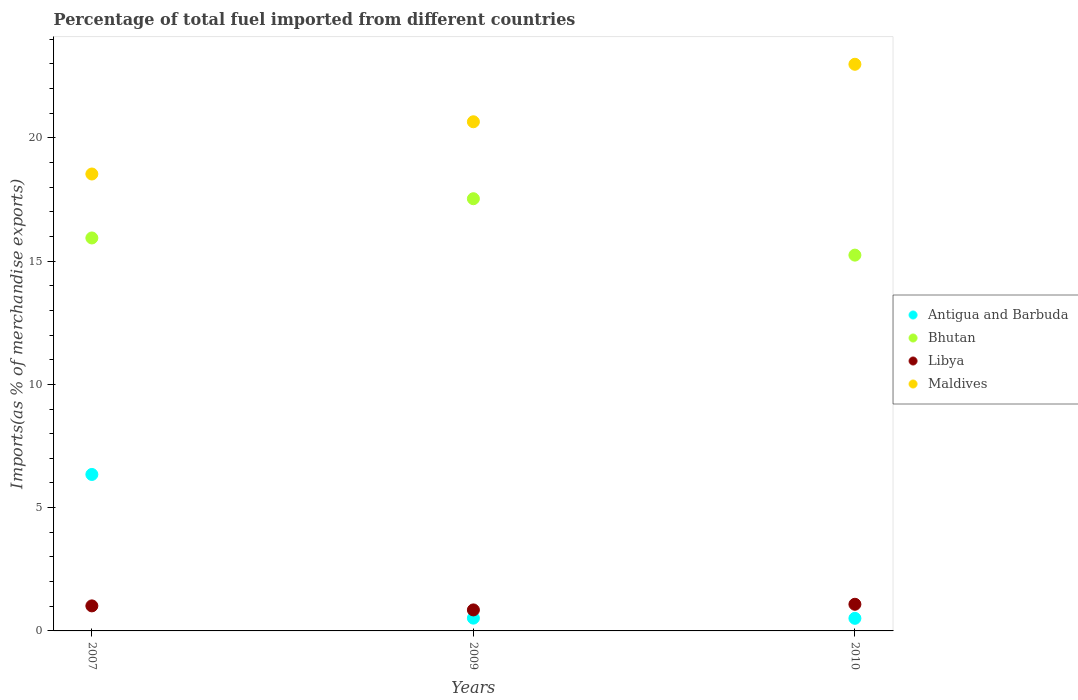How many different coloured dotlines are there?
Offer a terse response. 4. Is the number of dotlines equal to the number of legend labels?
Your answer should be compact. Yes. What is the percentage of imports to different countries in Libya in 2010?
Your answer should be compact. 1.08. Across all years, what is the maximum percentage of imports to different countries in Maldives?
Provide a succinct answer. 22.98. Across all years, what is the minimum percentage of imports to different countries in Bhutan?
Provide a short and direct response. 15.24. What is the total percentage of imports to different countries in Antigua and Barbuda in the graph?
Give a very brief answer. 7.38. What is the difference between the percentage of imports to different countries in Libya in 2009 and that in 2010?
Give a very brief answer. -0.23. What is the difference between the percentage of imports to different countries in Maldives in 2009 and the percentage of imports to different countries in Bhutan in 2007?
Offer a terse response. 4.71. What is the average percentage of imports to different countries in Bhutan per year?
Your answer should be very brief. 16.24. In the year 2010, what is the difference between the percentage of imports to different countries in Antigua and Barbuda and percentage of imports to different countries in Maldives?
Offer a terse response. -22.47. What is the ratio of the percentage of imports to different countries in Bhutan in 2009 to that in 2010?
Ensure brevity in your answer.  1.15. Is the percentage of imports to different countries in Antigua and Barbuda in 2007 less than that in 2010?
Offer a terse response. No. What is the difference between the highest and the second highest percentage of imports to different countries in Libya?
Your response must be concise. 0.07. What is the difference between the highest and the lowest percentage of imports to different countries in Maldives?
Your answer should be very brief. 4.45. In how many years, is the percentage of imports to different countries in Maldives greater than the average percentage of imports to different countries in Maldives taken over all years?
Your response must be concise. 1. Is the sum of the percentage of imports to different countries in Libya in 2007 and 2010 greater than the maximum percentage of imports to different countries in Bhutan across all years?
Your answer should be very brief. No. Is it the case that in every year, the sum of the percentage of imports to different countries in Antigua and Barbuda and percentage of imports to different countries in Libya  is greater than the percentage of imports to different countries in Maldives?
Offer a very short reply. No. Is the percentage of imports to different countries in Bhutan strictly greater than the percentage of imports to different countries in Antigua and Barbuda over the years?
Keep it short and to the point. Yes. How many dotlines are there?
Offer a terse response. 4. How many years are there in the graph?
Provide a short and direct response. 3. Does the graph contain grids?
Your response must be concise. No. How many legend labels are there?
Offer a terse response. 4. How are the legend labels stacked?
Ensure brevity in your answer.  Vertical. What is the title of the graph?
Offer a very short reply. Percentage of total fuel imported from different countries. What is the label or title of the X-axis?
Ensure brevity in your answer.  Years. What is the label or title of the Y-axis?
Give a very brief answer. Imports(as % of merchandise exports). What is the Imports(as % of merchandise exports) of Antigua and Barbuda in 2007?
Provide a succinct answer. 6.35. What is the Imports(as % of merchandise exports) in Bhutan in 2007?
Keep it short and to the point. 15.94. What is the Imports(as % of merchandise exports) in Libya in 2007?
Offer a terse response. 1.02. What is the Imports(as % of merchandise exports) of Maldives in 2007?
Make the answer very short. 18.53. What is the Imports(as % of merchandise exports) in Antigua and Barbuda in 2009?
Keep it short and to the point. 0.52. What is the Imports(as % of merchandise exports) in Bhutan in 2009?
Keep it short and to the point. 17.53. What is the Imports(as % of merchandise exports) in Libya in 2009?
Offer a terse response. 0.85. What is the Imports(as % of merchandise exports) of Maldives in 2009?
Give a very brief answer. 20.65. What is the Imports(as % of merchandise exports) in Antigua and Barbuda in 2010?
Provide a succinct answer. 0.51. What is the Imports(as % of merchandise exports) of Bhutan in 2010?
Offer a terse response. 15.24. What is the Imports(as % of merchandise exports) in Libya in 2010?
Your response must be concise. 1.08. What is the Imports(as % of merchandise exports) in Maldives in 2010?
Provide a short and direct response. 22.98. Across all years, what is the maximum Imports(as % of merchandise exports) of Antigua and Barbuda?
Your answer should be very brief. 6.35. Across all years, what is the maximum Imports(as % of merchandise exports) in Bhutan?
Provide a succinct answer. 17.53. Across all years, what is the maximum Imports(as % of merchandise exports) of Libya?
Ensure brevity in your answer.  1.08. Across all years, what is the maximum Imports(as % of merchandise exports) of Maldives?
Provide a succinct answer. 22.98. Across all years, what is the minimum Imports(as % of merchandise exports) of Antigua and Barbuda?
Ensure brevity in your answer.  0.51. Across all years, what is the minimum Imports(as % of merchandise exports) in Bhutan?
Ensure brevity in your answer.  15.24. Across all years, what is the minimum Imports(as % of merchandise exports) of Libya?
Keep it short and to the point. 0.85. Across all years, what is the minimum Imports(as % of merchandise exports) of Maldives?
Give a very brief answer. 18.53. What is the total Imports(as % of merchandise exports) of Antigua and Barbuda in the graph?
Give a very brief answer. 7.38. What is the total Imports(as % of merchandise exports) of Bhutan in the graph?
Provide a succinct answer. 48.71. What is the total Imports(as % of merchandise exports) in Libya in the graph?
Keep it short and to the point. 2.95. What is the total Imports(as % of merchandise exports) of Maldives in the graph?
Keep it short and to the point. 62.16. What is the difference between the Imports(as % of merchandise exports) of Antigua and Barbuda in 2007 and that in 2009?
Your answer should be very brief. 5.83. What is the difference between the Imports(as % of merchandise exports) of Bhutan in 2007 and that in 2009?
Provide a short and direct response. -1.59. What is the difference between the Imports(as % of merchandise exports) in Libya in 2007 and that in 2009?
Ensure brevity in your answer.  0.16. What is the difference between the Imports(as % of merchandise exports) of Maldives in 2007 and that in 2009?
Offer a terse response. -2.12. What is the difference between the Imports(as % of merchandise exports) in Antigua and Barbuda in 2007 and that in 2010?
Offer a terse response. 5.84. What is the difference between the Imports(as % of merchandise exports) in Bhutan in 2007 and that in 2010?
Offer a terse response. 0.7. What is the difference between the Imports(as % of merchandise exports) of Libya in 2007 and that in 2010?
Offer a very short reply. -0.07. What is the difference between the Imports(as % of merchandise exports) of Maldives in 2007 and that in 2010?
Your response must be concise. -4.45. What is the difference between the Imports(as % of merchandise exports) in Antigua and Barbuda in 2009 and that in 2010?
Ensure brevity in your answer.  0.01. What is the difference between the Imports(as % of merchandise exports) of Bhutan in 2009 and that in 2010?
Your answer should be compact. 2.29. What is the difference between the Imports(as % of merchandise exports) of Libya in 2009 and that in 2010?
Ensure brevity in your answer.  -0.23. What is the difference between the Imports(as % of merchandise exports) in Maldives in 2009 and that in 2010?
Your response must be concise. -2.33. What is the difference between the Imports(as % of merchandise exports) in Antigua and Barbuda in 2007 and the Imports(as % of merchandise exports) in Bhutan in 2009?
Provide a short and direct response. -11.18. What is the difference between the Imports(as % of merchandise exports) in Antigua and Barbuda in 2007 and the Imports(as % of merchandise exports) in Libya in 2009?
Offer a terse response. 5.49. What is the difference between the Imports(as % of merchandise exports) of Antigua and Barbuda in 2007 and the Imports(as % of merchandise exports) of Maldives in 2009?
Your answer should be very brief. -14.3. What is the difference between the Imports(as % of merchandise exports) in Bhutan in 2007 and the Imports(as % of merchandise exports) in Libya in 2009?
Keep it short and to the point. 15.09. What is the difference between the Imports(as % of merchandise exports) of Bhutan in 2007 and the Imports(as % of merchandise exports) of Maldives in 2009?
Give a very brief answer. -4.71. What is the difference between the Imports(as % of merchandise exports) in Libya in 2007 and the Imports(as % of merchandise exports) in Maldives in 2009?
Offer a terse response. -19.64. What is the difference between the Imports(as % of merchandise exports) in Antigua and Barbuda in 2007 and the Imports(as % of merchandise exports) in Bhutan in 2010?
Ensure brevity in your answer.  -8.9. What is the difference between the Imports(as % of merchandise exports) of Antigua and Barbuda in 2007 and the Imports(as % of merchandise exports) of Libya in 2010?
Offer a very short reply. 5.27. What is the difference between the Imports(as % of merchandise exports) of Antigua and Barbuda in 2007 and the Imports(as % of merchandise exports) of Maldives in 2010?
Keep it short and to the point. -16.64. What is the difference between the Imports(as % of merchandise exports) of Bhutan in 2007 and the Imports(as % of merchandise exports) of Libya in 2010?
Keep it short and to the point. 14.86. What is the difference between the Imports(as % of merchandise exports) in Bhutan in 2007 and the Imports(as % of merchandise exports) in Maldives in 2010?
Provide a short and direct response. -7.04. What is the difference between the Imports(as % of merchandise exports) of Libya in 2007 and the Imports(as % of merchandise exports) of Maldives in 2010?
Your answer should be very brief. -21.97. What is the difference between the Imports(as % of merchandise exports) in Antigua and Barbuda in 2009 and the Imports(as % of merchandise exports) in Bhutan in 2010?
Offer a very short reply. -14.72. What is the difference between the Imports(as % of merchandise exports) in Antigua and Barbuda in 2009 and the Imports(as % of merchandise exports) in Libya in 2010?
Ensure brevity in your answer.  -0.56. What is the difference between the Imports(as % of merchandise exports) of Antigua and Barbuda in 2009 and the Imports(as % of merchandise exports) of Maldives in 2010?
Your response must be concise. -22.46. What is the difference between the Imports(as % of merchandise exports) in Bhutan in 2009 and the Imports(as % of merchandise exports) in Libya in 2010?
Ensure brevity in your answer.  16.45. What is the difference between the Imports(as % of merchandise exports) of Bhutan in 2009 and the Imports(as % of merchandise exports) of Maldives in 2010?
Make the answer very short. -5.45. What is the difference between the Imports(as % of merchandise exports) in Libya in 2009 and the Imports(as % of merchandise exports) in Maldives in 2010?
Offer a terse response. -22.13. What is the average Imports(as % of merchandise exports) of Antigua and Barbuda per year?
Offer a terse response. 2.46. What is the average Imports(as % of merchandise exports) in Bhutan per year?
Your answer should be compact. 16.24. What is the average Imports(as % of merchandise exports) of Libya per year?
Provide a succinct answer. 0.98. What is the average Imports(as % of merchandise exports) in Maldives per year?
Offer a terse response. 20.72. In the year 2007, what is the difference between the Imports(as % of merchandise exports) in Antigua and Barbuda and Imports(as % of merchandise exports) in Bhutan?
Give a very brief answer. -9.59. In the year 2007, what is the difference between the Imports(as % of merchandise exports) in Antigua and Barbuda and Imports(as % of merchandise exports) in Libya?
Make the answer very short. 5.33. In the year 2007, what is the difference between the Imports(as % of merchandise exports) in Antigua and Barbuda and Imports(as % of merchandise exports) in Maldives?
Your answer should be very brief. -12.19. In the year 2007, what is the difference between the Imports(as % of merchandise exports) of Bhutan and Imports(as % of merchandise exports) of Libya?
Your response must be concise. 14.92. In the year 2007, what is the difference between the Imports(as % of merchandise exports) in Bhutan and Imports(as % of merchandise exports) in Maldives?
Offer a very short reply. -2.59. In the year 2007, what is the difference between the Imports(as % of merchandise exports) in Libya and Imports(as % of merchandise exports) in Maldives?
Ensure brevity in your answer.  -17.52. In the year 2009, what is the difference between the Imports(as % of merchandise exports) of Antigua and Barbuda and Imports(as % of merchandise exports) of Bhutan?
Your response must be concise. -17.01. In the year 2009, what is the difference between the Imports(as % of merchandise exports) of Antigua and Barbuda and Imports(as % of merchandise exports) of Libya?
Give a very brief answer. -0.33. In the year 2009, what is the difference between the Imports(as % of merchandise exports) in Antigua and Barbuda and Imports(as % of merchandise exports) in Maldives?
Your answer should be very brief. -20.13. In the year 2009, what is the difference between the Imports(as % of merchandise exports) of Bhutan and Imports(as % of merchandise exports) of Libya?
Provide a short and direct response. 16.68. In the year 2009, what is the difference between the Imports(as % of merchandise exports) in Bhutan and Imports(as % of merchandise exports) in Maldives?
Your response must be concise. -3.12. In the year 2009, what is the difference between the Imports(as % of merchandise exports) of Libya and Imports(as % of merchandise exports) of Maldives?
Give a very brief answer. -19.8. In the year 2010, what is the difference between the Imports(as % of merchandise exports) of Antigua and Barbuda and Imports(as % of merchandise exports) of Bhutan?
Provide a succinct answer. -14.73. In the year 2010, what is the difference between the Imports(as % of merchandise exports) in Antigua and Barbuda and Imports(as % of merchandise exports) in Libya?
Offer a very short reply. -0.57. In the year 2010, what is the difference between the Imports(as % of merchandise exports) in Antigua and Barbuda and Imports(as % of merchandise exports) in Maldives?
Your response must be concise. -22.47. In the year 2010, what is the difference between the Imports(as % of merchandise exports) of Bhutan and Imports(as % of merchandise exports) of Libya?
Your answer should be very brief. 14.16. In the year 2010, what is the difference between the Imports(as % of merchandise exports) of Bhutan and Imports(as % of merchandise exports) of Maldives?
Make the answer very short. -7.74. In the year 2010, what is the difference between the Imports(as % of merchandise exports) of Libya and Imports(as % of merchandise exports) of Maldives?
Your response must be concise. -21.9. What is the ratio of the Imports(as % of merchandise exports) of Antigua and Barbuda in 2007 to that in 2009?
Keep it short and to the point. 12.23. What is the ratio of the Imports(as % of merchandise exports) in Bhutan in 2007 to that in 2009?
Give a very brief answer. 0.91. What is the ratio of the Imports(as % of merchandise exports) in Libya in 2007 to that in 2009?
Ensure brevity in your answer.  1.19. What is the ratio of the Imports(as % of merchandise exports) in Maldives in 2007 to that in 2009?
Your answer should be compact. 0.9. What is the ratio of the Imports(as % of merchandise exports) in Antigua and Barbuda in 2007 to that in 2010?
Offer a very short reply. 12.42. What is the ratio of the Imports(as % of merchandise exports) in Bhutan in 2007 to that in 2010?
Provide a short and direct response. 1.05. What is the ratio of the Imports(as % of merchandise exports) in Libya in 2007 to that in 2010?
Your response must be concise. 0.94. What is the ratio of the Imports(as % of merchandise exports) of Maldives in 2007 to that in 2010?
Provide a short and direct response. 0.81. What is the ratio of the Imports(as % of merchandise exports) in Antigua and Barbuda in 2009 to that in 2010?
Ensure brevity in your answer.  1.02. What is the ratio of the Imports(as % of merchandise exports) of Bhutan in 2009 to that in 2010?
Give a very brief answer. 1.15. What is the ratio of the Imports(as % of merchandise exports) of Libya in 2009 to that in 2010?
Make the answer very short. 0.79. What is the ratio of the Imports(as % of merchandise exports) in Maldives in 2009 to that in 2010?
Provide a short and direct response. 0.9. What is the difference between the highest and the second highest Imports(as % of merchandise exports) of Antigua and Barbuda?
Your response must be concise. 5.83. What is the difference between the highest and the second highest Imports(as % of merchandise exports) in Bhutan?
Keep it short and to the point. 1.59. What is the difference between the highest and the second highest Imports(as % of merchandise exports) of Libya?
Give a very brief answer. 0.07. What is the difference between the highest and the second highest Imports(as % of merchandise exports) in Maldives?
Ensure brevity in your answer.  2.33. What is the difference between the highest and the lowest Imports(as % of merchandise exports) of Antigua and Barbuda?
Give a very brief answer. 5.84. What is the difference between the highest and the lowest Imports(as % of merchandise exports) in Bhutan?
Ensure brevity in your answer.  2.29. What is the difference between the highest and the lowest Imports(as % of merchandise exports) of Libya?
Give a very brief answer. 0.23. What is the difference between the highest and the lowest Imports(as % of merchandise exports) of Maldives?
Your answer should be compact. 4.45. 